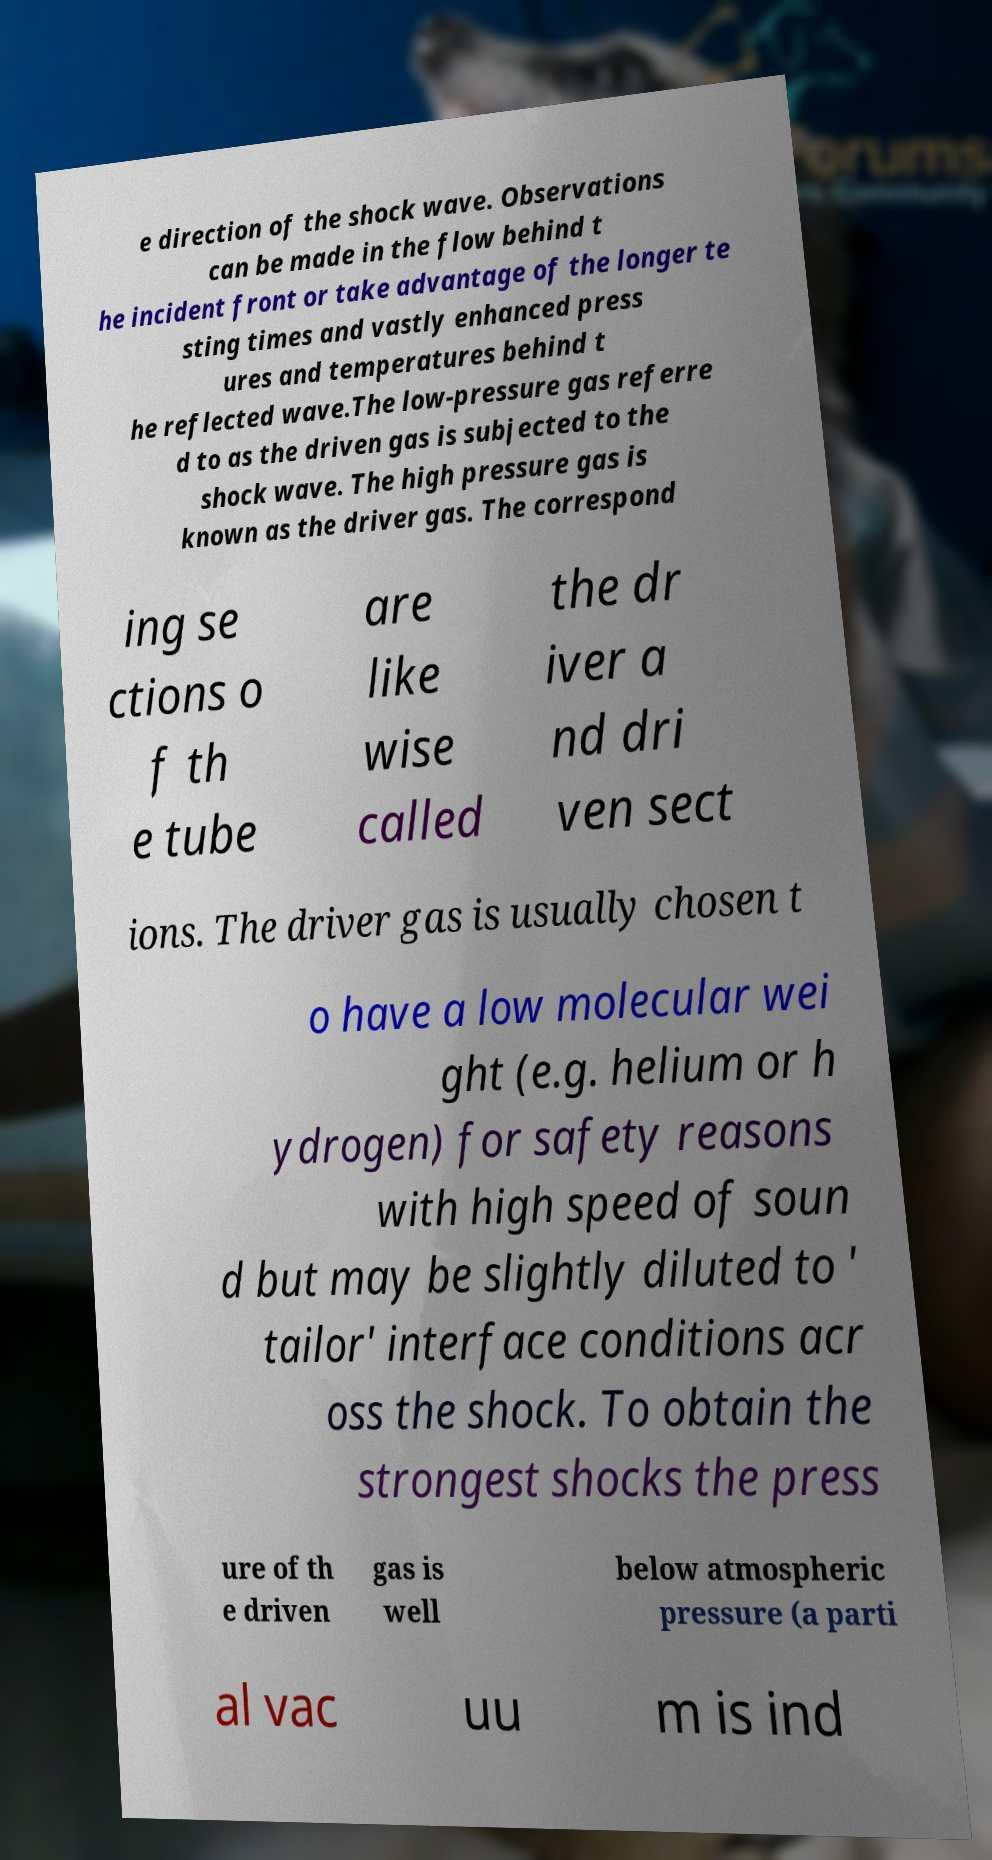Can you accurately transcribe the text from the provided image for me? e direction of the shock wave. Observations can be made in the flow behind t he incident front or take advantage of the longer te sting times and vastly enhanced press ures and temperatures behind t he reflected wave.The low-pressure gas referre d to as the driven gas is subjected to the shock wave. The high pressure gas is known as the driver gas. The correspond ing se ctions o f th e tube are like wise called the dr iver a nd dri ven sect ions. The driver gas is usually chosen t o have a low molecular wei ght (e.g. helium or h ydrogen) for safety reasons with high speed of soun d but may be slightly diluted to ' tailor' interface conditions acr oss the shock. To obtain the strongest shocks the press ure of th e driven gas is well below atmospheric pressure (a parti al vac uu m is ind 